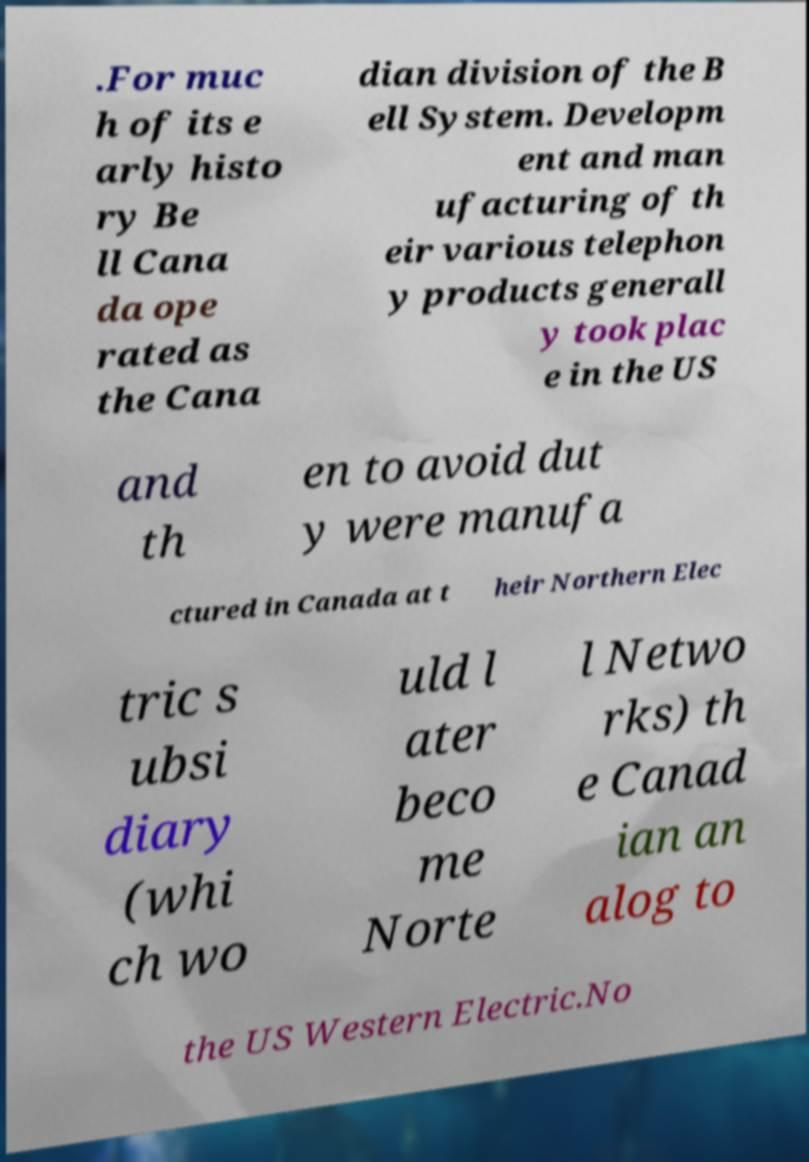Please read and relay the text visible in this image. What does it say? .For muc h of its e arly histo ry Be ll Cana da ope rated as the Cana dian division of the B ell System. Developm ent and man ufacturing of th eir various telephon y products generall y took plac e in the US and th en to avoid dut y were manufa ctured in Canada at t heir Northern Elec tric s ubsi diary (whi ch wo uld l ater beco me Norte l Netwo rks) th e Canad ian an alog to the US Western Electric.No 